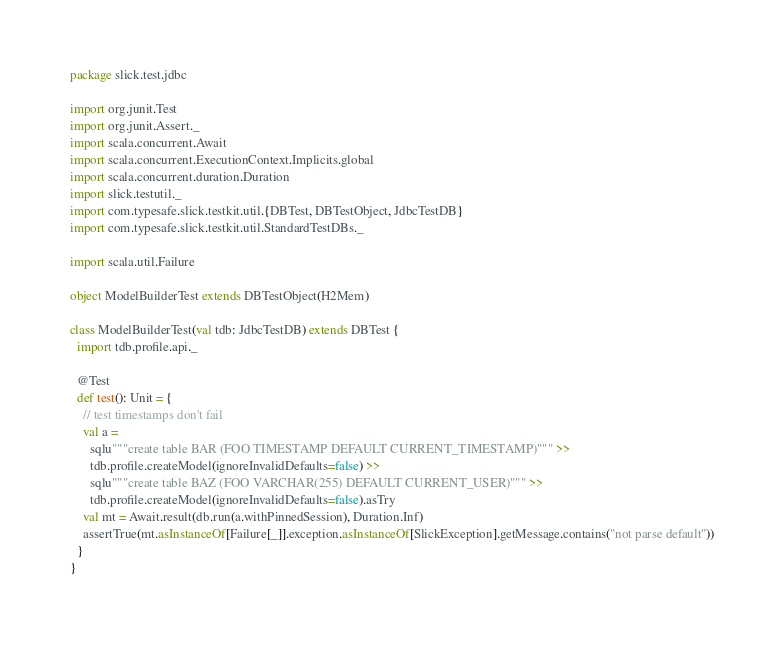Convert code to text. <code><loc_0><loc_0><loc_500><loc_500><_Scala_>package slick.test.jdbc

import org.junit.Test
import org.junit.Assert._
import scala.concurrent.Await
import scala.concurrent.ExecutionContext.Implicits.global
import scala.concurrent.duration.Duration
import slick.testutil._
import com.typesafe.slick.testkit.util.{DBTest, DBTestObject, JdbcTestDB}
import com.typesafe.slick.testkit.util.StandardTestDBs._

import scala.util.Failure

object ModelBuilderTest extends DBTestObject(H2Mem)

class ModelBuilderTest(val tdb: JdbcTestDB) extends DBTest {
  import tdb.profile.api._

  @Test
  def test(): Unit = {
    // test timestamps don't fail
    val a =
      sqlu"""create table BAR (FOO TIMESTAMP DEFAULT CURRENT_TIMESTAMP)""" >>
      tdb.profile.createModel(ignoreInvalidDefaults=false) >>
      sqlu"""create table BAZ (FOO VARCHAR(255) DEFAULT CURRENT_USER)""" >>
      tdb.profile.createModel(ignoreInvalidDefaults=false).asTry
    val mt = Await.result(db.run(a.withPinnedSession), Duration.Inf)
    assertTrue(mt.asInstanceOf[Failure[_]].exception.asInstanceOf[SlickException].getMessage.contains("not parse default"))
  }
}
</code> 